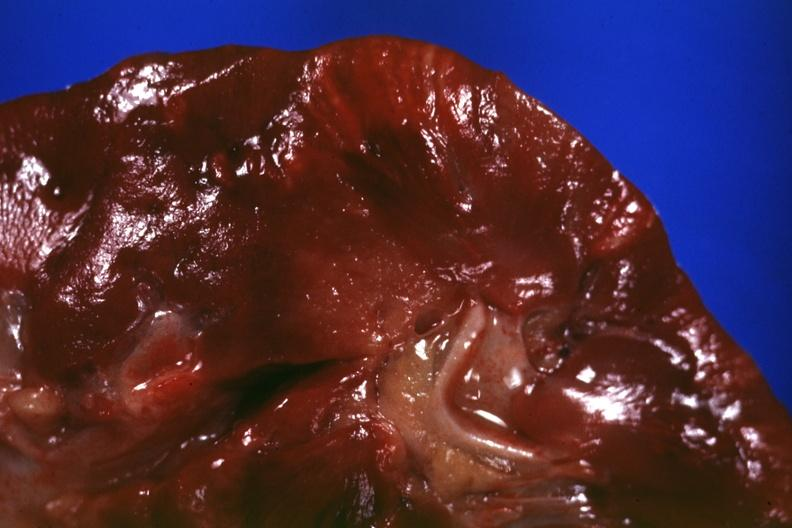s myocardium present?
Answer the question using a single word or phrase. No 